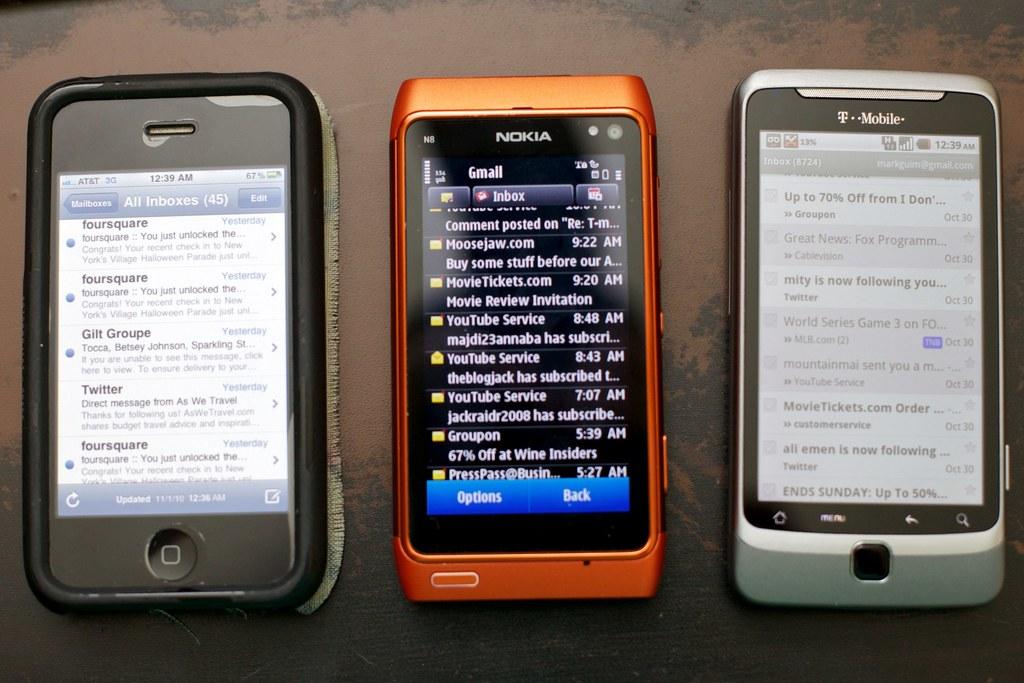Which of these is a nokia?
Ensure brevity in your answer.  Middle. 